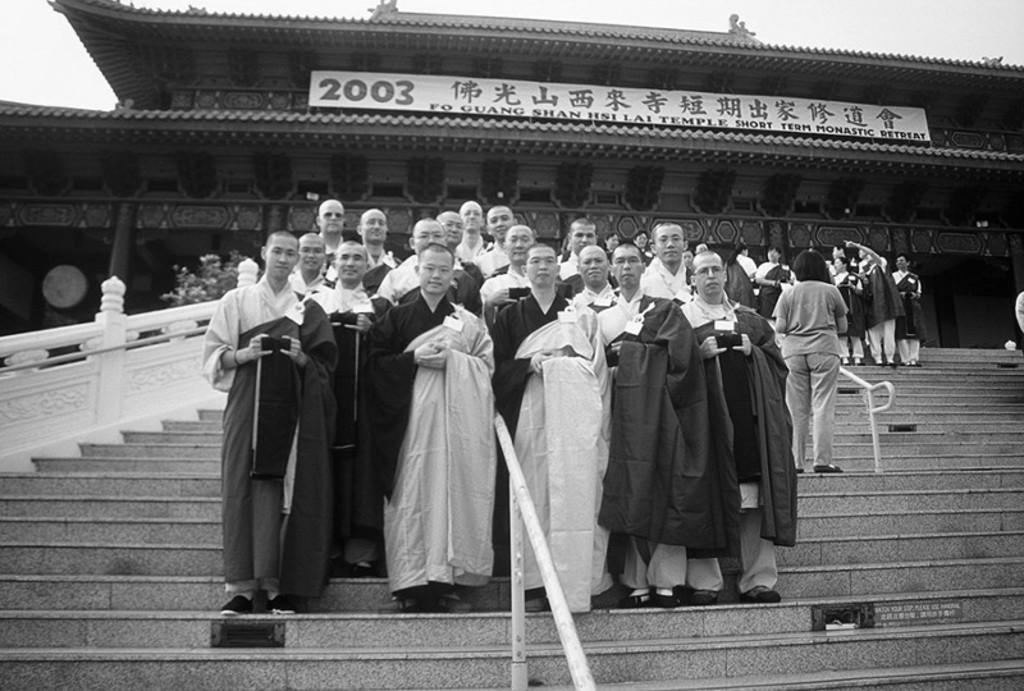In one or two sentences, can you explain what this image depicts? This is a black and white image, where we can see a group of men standing on the stairs. In the background, there are few persons standing, a building and a banner to it, a tree and the sky. 